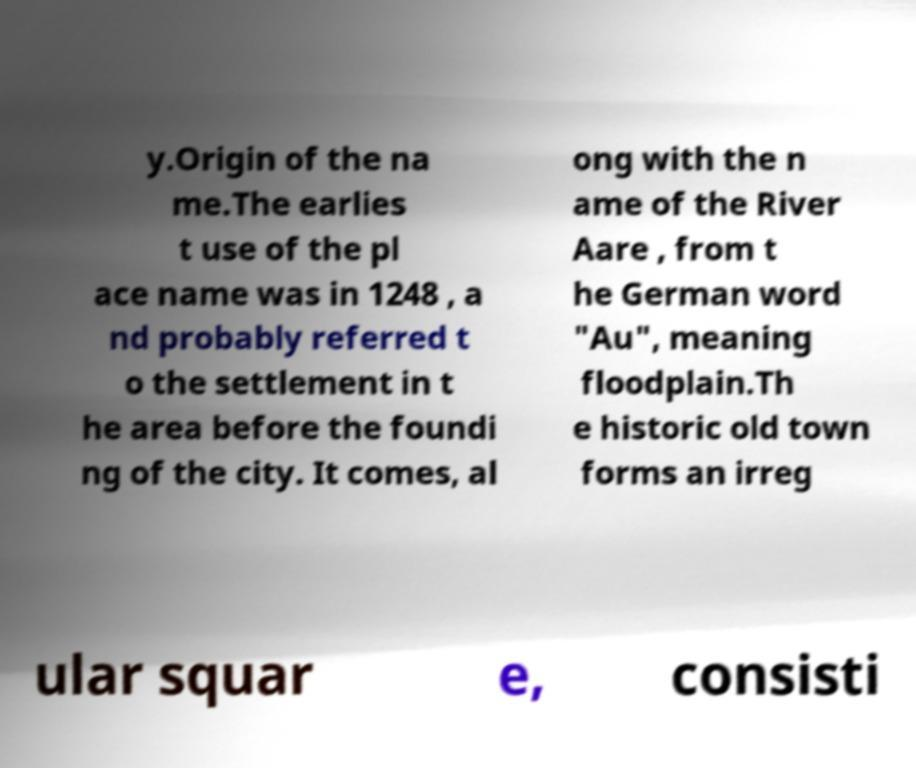Please identify and transcribe the text found in this image. y.Origin of the na me.The earlies t use of the pl ace name was in 1248 , a nd probably referred t o the settlement in t he area before the foundi ng of the city. It comes, al ong with the n ame of the River Aare , from t he German word "Au", meaning floodplain.Th e historic old town forms an irreg ular squar e, consisti 